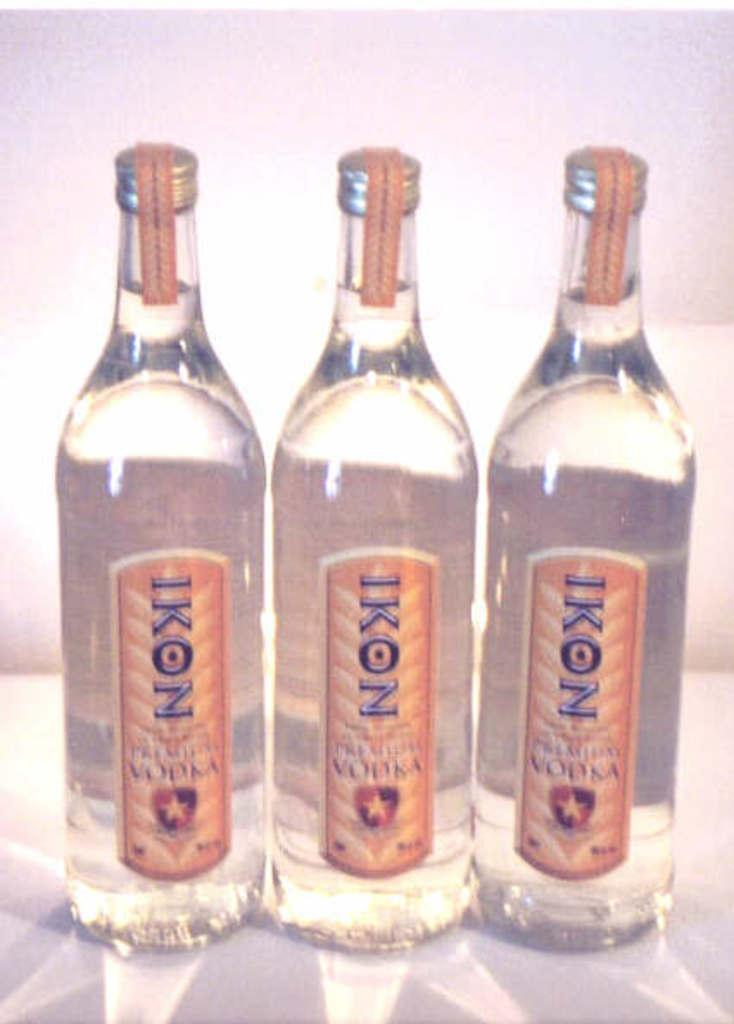How many bottles are visible in the image? There are three bottles in the image. What is inside the bottles? The bottles contain vodka. What is written on the bottles? The bottles have "IKON" written on them. What type of hat is the worm wearing in the image? There is no worm or hat present in the image. Is the volleyball visible in the image? There is no volleyball present in the image. 